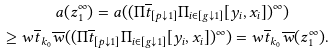Convert formula to latex. <formula><loc_0><loc_0><loc_500><loc_500>a ( z _ { 1 } ^ { \infty } ) = a ( ( \Pi \overline { t } _ { [ p { \downarrow } 1 ] } \Pi _ { i \in [ g { \downarrow } 1 ] } [ y _ { i } , x _ { i } ] ) ^ { \infty } ) \quad \, \\ \geq w \overline { t } _ { k _ { 0 } } \overline { w } ( ( \Pi \overline { t } _ { [ p { \downarrow } 1 ] } \Pi _ { i \in [ g { \downarrow } 1 ] } [ y _ { i } , x _ { i } ] ) ^ { \infty } ) = w \overline { t } _ { k _ { 0 } } \overline { w } ( z _ { 1 } ^ { \infty } ) .</formula> 